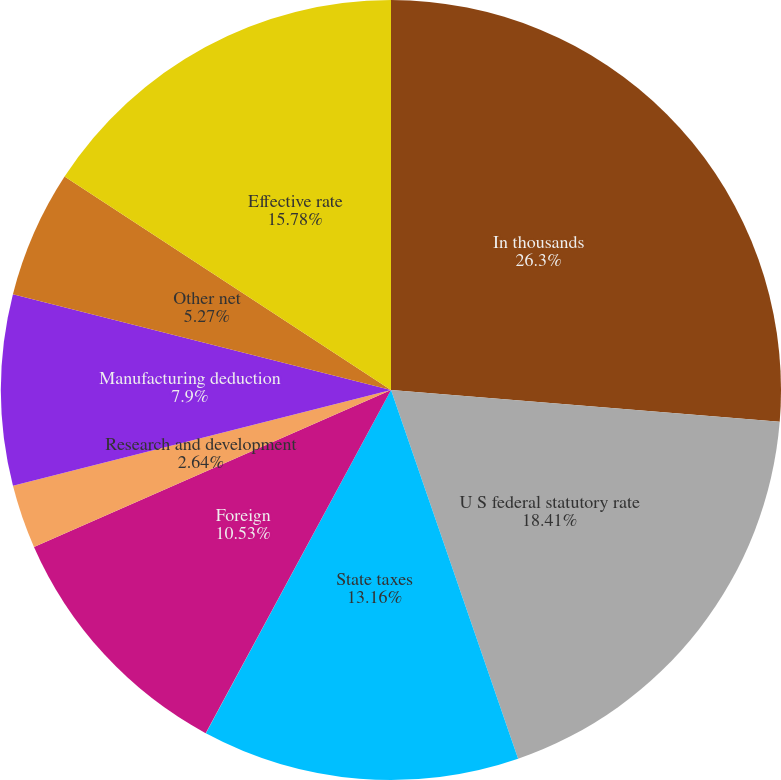Convert chart to OTSL. <chart><loc_0><loc_0><loc_500><loc_500><pie_chart><fcel>In thousands<fcel>U S federal statutory rate<fcel>State taxes<fcel>Tax reserves<fcel>Foreign<fcel>Research and development<fcel>Manufacturing deduction<fcel>Other net<fcel>Effective rate<nl><fcel>26.31%<fcel>18.42%<fcel>13.16%<fcel>0.01%<fcel>10.53%<fcel>2.64%<fcel>7.9%<fcel>5.27%<fcel>15.79%<nl></chart> 